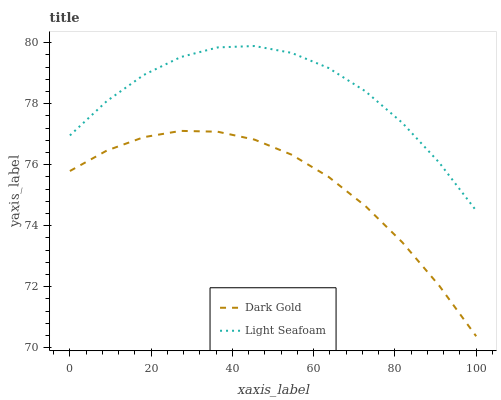Does Dark Gold have the minimum area under the curve?
Answer yes or no. Yes. Does Light Seafoam have the maximum area under the curve?
Answer yes or no. Yes. Does Dark Gold have the maximum area under the curve?
Answer yes or no. No. Is Dark Gold the smoothest?
Answer yes or no. Yes. Is Light Seafoam the roughest?
Answer yes or no. Yes. Is Dark Gold the roughest?
Answer yes or no. No. Does Dark Gold have the lowest value?
Answer yes or no. Yes. Does Light Seafoam have the highest value?
Answer yes or no. Yes. Does Dark Gold have the highest value?
Answer yes or no. No. Is Dark Gold less than Light Seafoam?
Answer yes or no. Yes. Is Light Seafoam greater than Dark Gold?
Answer yes or no. Yes. Does Dark Gold intersect Light Seafoam?
Answer yes or no. No. 